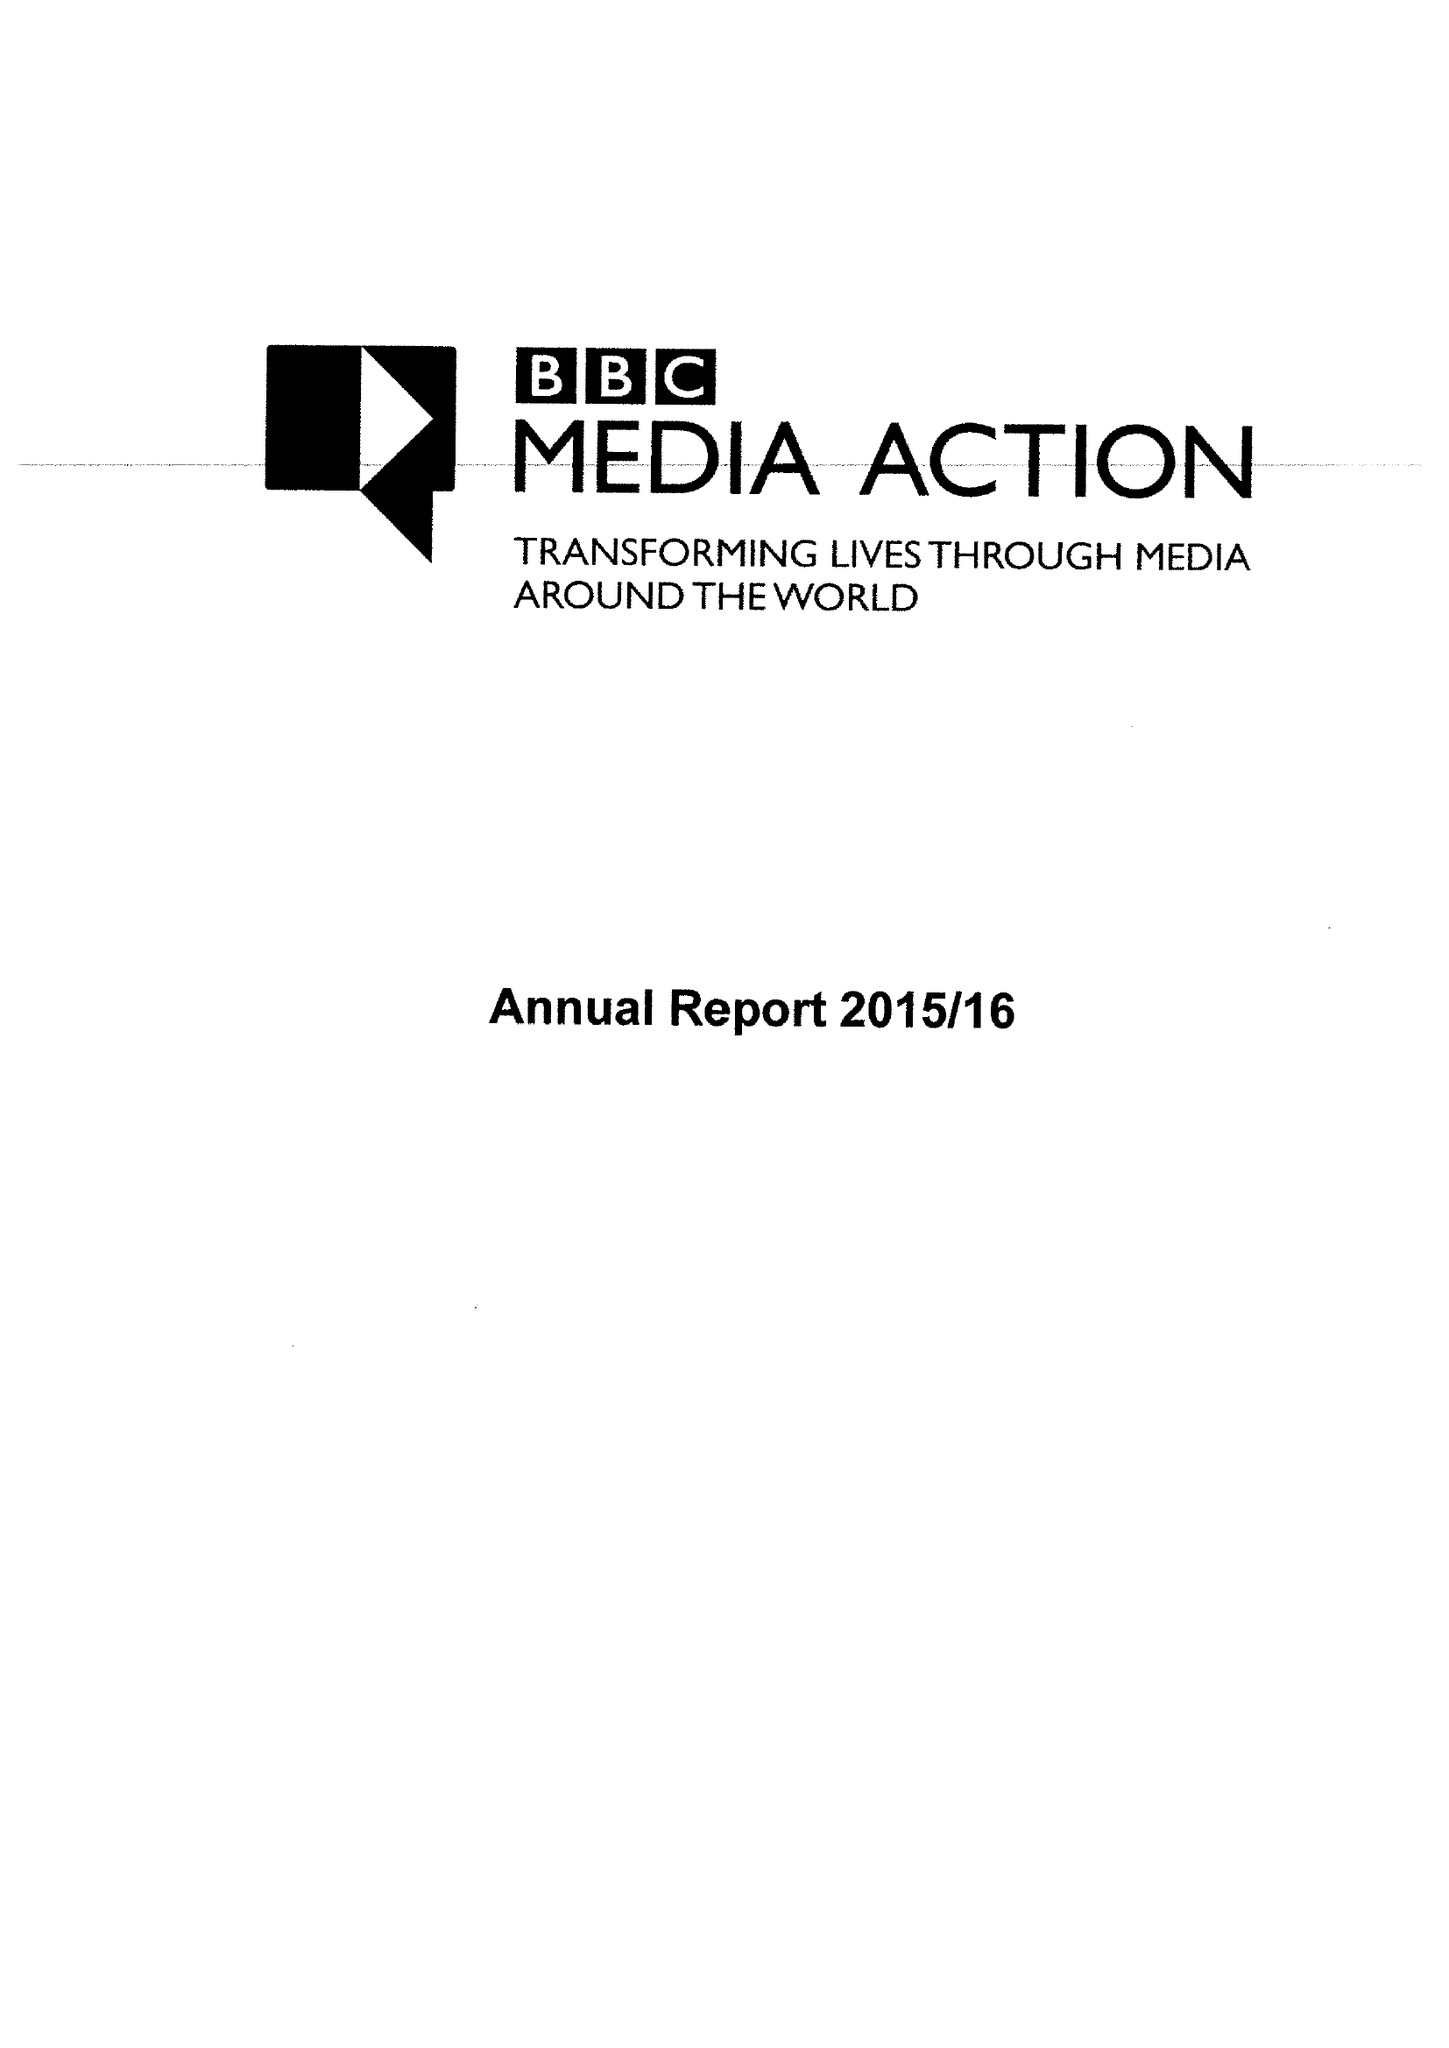What is the value for the spending_annually_in_british_pounds?
Answer the question using a single word or phrase. 43953000.00 